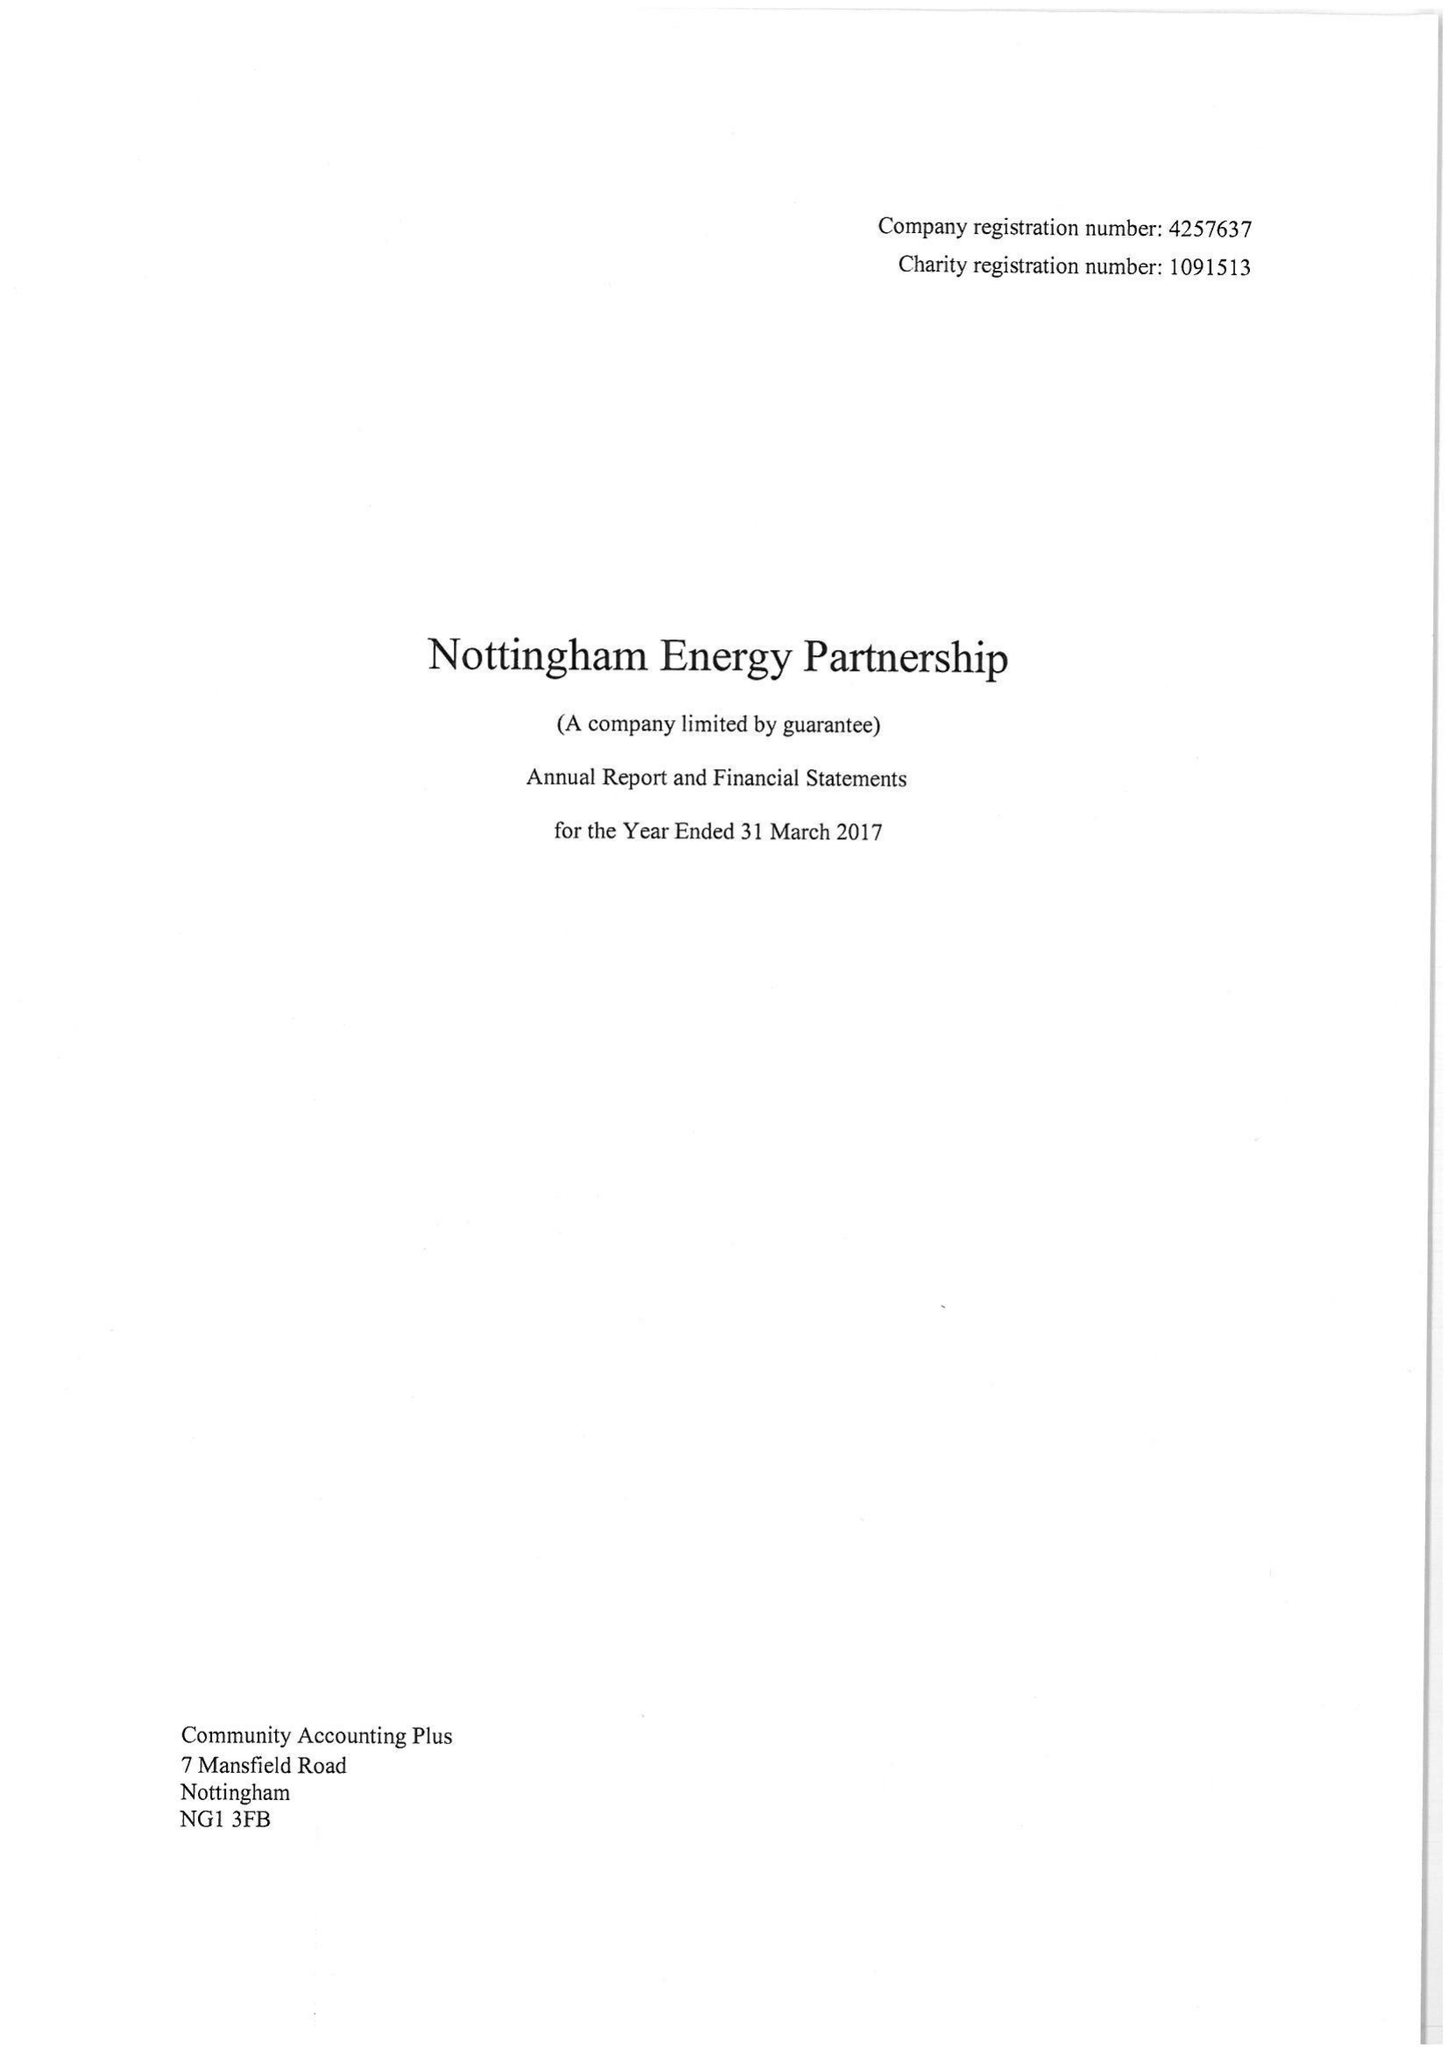What is the value for the spending_annually_in_british_pounds?
Answer the question using a single word or phrase. 506347.00 